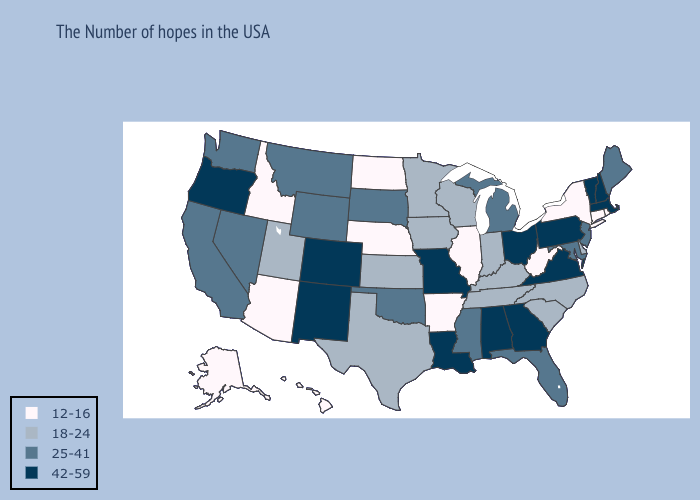What is the lowest value in the Northeast?
Give a very brief answer. 12-16. Among the states that border New Mexico , does Utah have the lowest value?
Answer briefly. No. Which states have the highest value in the USA?
Be succinct. Massachusetts, New Hampshire, Vermont, Pennsylvania, Virginia, Ohio, Georgia, Alabama, Louisiana, Missouri, Colorado, New Mexico, Oregon. Does Florida have a lower value than South Carolina?
Short answer required. No. Name the states that have a value in the range 18-24?
Keep it brief. Delaware, North Carolina, South Carolina, Kentucky, Indiana, Tennessee, Wisconsin, Minnesota, Iowa, Kansas, Texas, Utah. What is the lowest value in the MidWest?
Write a very short answer. 12-16. How many symbols are there in the legend?
Quick response, please. 4. What is the value of Utah?
Answer briefly. 18-24. What is the value of Arizona?
Write a very short answer. 12-16. Does South Dakota have a higher value than South Carolina?
Short answer required. Yes. Does New Jersey have the lowest value in the Northeast?
Write a very short answer. No. Does Illinois have a lower value than Rhode Island?
Answer briefly. No. What is the value of Pennsylvania?
Short answer required. 42-59. Among the states that border Mississippi , which have the lowest value?
Quick response, please. Arkansas. Does Delaware have the lowest value in the South?
Keep it brief. No. 